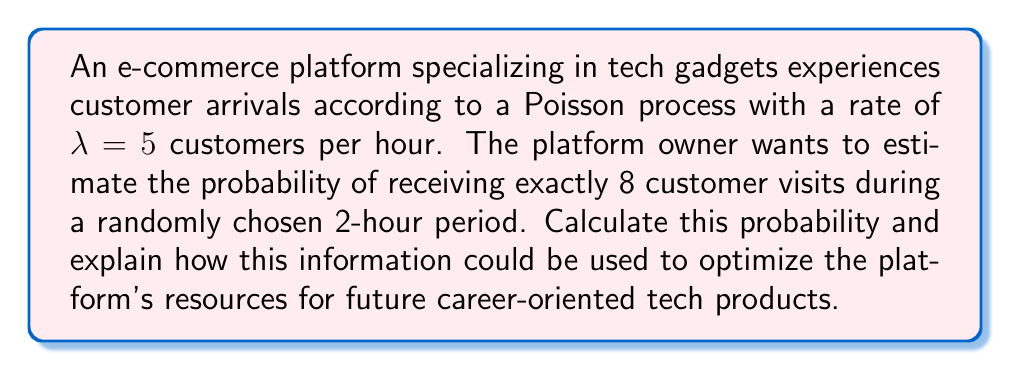Provide a solution to this math problem. Let's approach this step-by-step:

1) In a Poisson process, the number of events (customer arrivals) in a fixed time interval follows a Poisson distribution.

2) The Poisson distribution has a single parameter $\mu$, which is the expected number of events in the given interval.

3) For our case:
   $\lambda = 5$ customers/hour
   Time interval = 2 hours
   $\mu = \lambda \times \text{time} = 5 \times 2 = 10$

4) The probability mass function for a Poisson distribution is:

   $$P(X = k) = \frac{e^{-\mu} \mu^k}{k!}$$

   where $k$ is the number of events we're interested in (8 in this case).

5) Substituting our values:

   $$P(X = 8) = \frac{e^{-10} 10^8}{8!}$$

6) Calculating this (you can use a calculator):

   $$P(X = 8) \approx 0.1126$$

7) Therefore, the probability of exactly 8 customer visits in a 2-hour period is about 11.26%.

This information can be used to optimize the platform's resources for future career-oriented tech products in several ways:

a) Staffing: Ensure adequate customer support during peak hours.
b) Server capacity: Allocate appropriate server resources to handle expected traffic.
c) Inventory management: Stock popular tech gadgets based on expected demand.
d) Marketing strategies: Time promotional campaigns to coincide with periods of higher expected traffic.
e) Educational content: Prepare career-oriented tech product information for expected customer influx.

Understanding these patterns helps in efficiently allocating resources and improving the overall customer experience, which is crucial for a platform specializing in career-enhancing tech products.
Answer: 0.1126 or 11.26% 